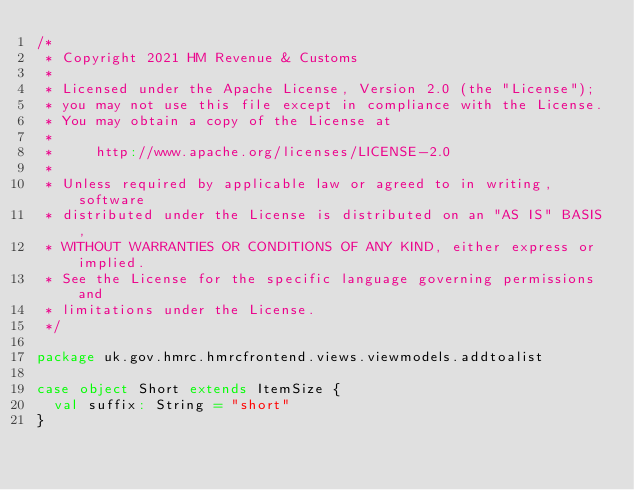<code> <loc_0><loc_0><loc_500><loc_500><_Scala_>/*
 * Copyright 2021 HM Revenue & Customs
 *
 * Licensed under the Apache License, Version 2.0 (the "License");
 * you may not use this file except in compliance with the License.
 * You may obtain a copy of the License at
 *
 *     http://www.apache.org/licenses/LICENSE-2.0
 *
 * Unless required by applicable law or agreed to in writing, software
 * distributed under the License is distributed on an "AS IS" BASIS,
 * WITHOUT WARRANTIES OR CONDITIONS OF ANY KIND, either express or implied.
 * See the License for the specific language governing permissions and
 * limitations under the License.
 */

package uk.gov.hmrc.hmrcfrontend.views.viewmodels.addtoalist

case object Short extends ItemSize {
  val suffix: String = "short"
}
</code> 